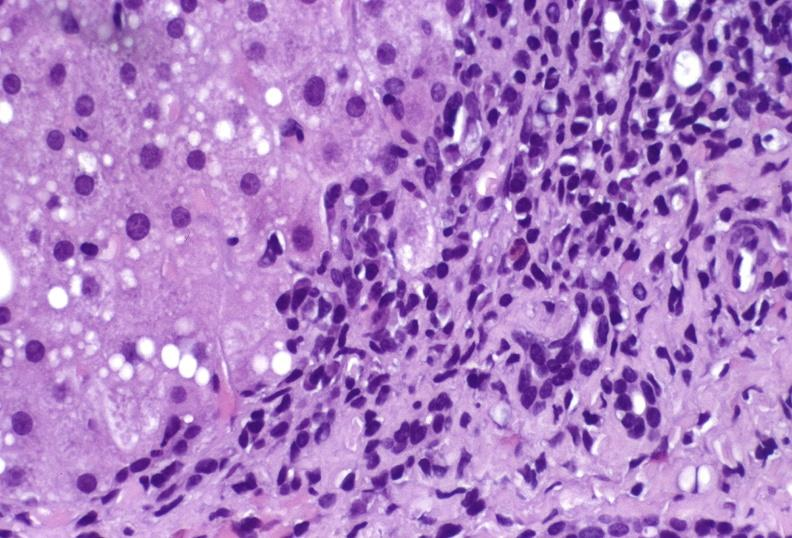s feet present?
Answer the question using a single word or phrase. No 